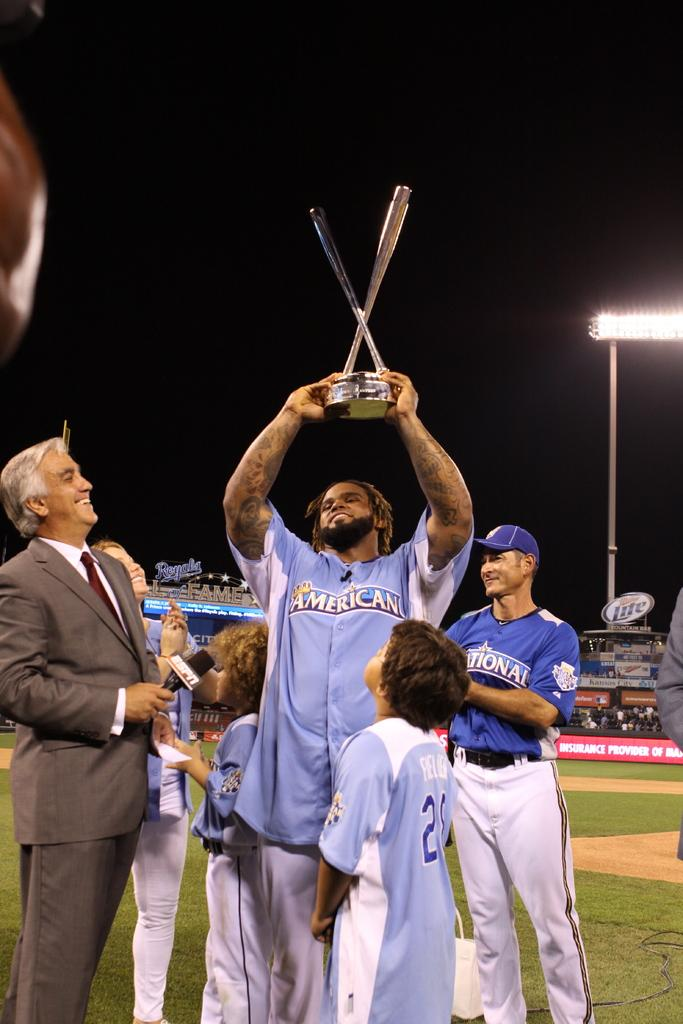<image>
Summarize the visual content of the image. A man in a blue sports uniform with the logo for americano on his chest is holding up a trophy over his head. 